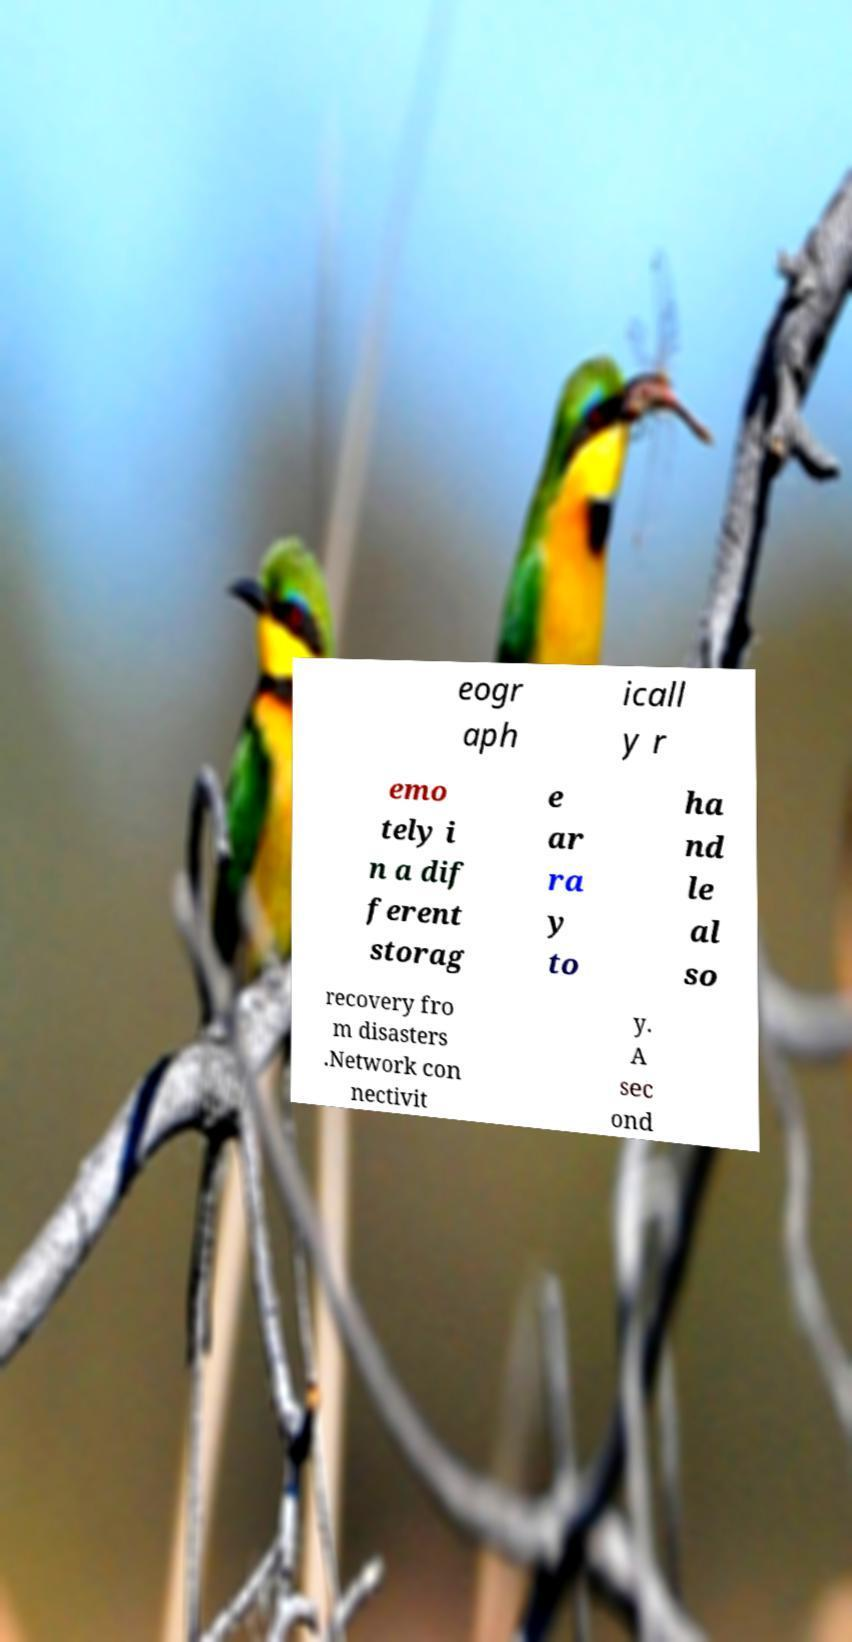There's text embedded in this image that I need extracted. Can you transcribe it verbatim? eogr aph icall y r emo tely i n a dif ferent storag e ar ra y to ha nd le al so recovery fro m disasters .Network con nectivit y. A sec ond 